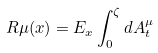<formula> <loc_0><loc_0><loc_500><loc_500>R \mu ( x ) = E _ { x } \int ^ { \zeta } _ { 0 } d A ^ { \mu } _ { t }</formula> 